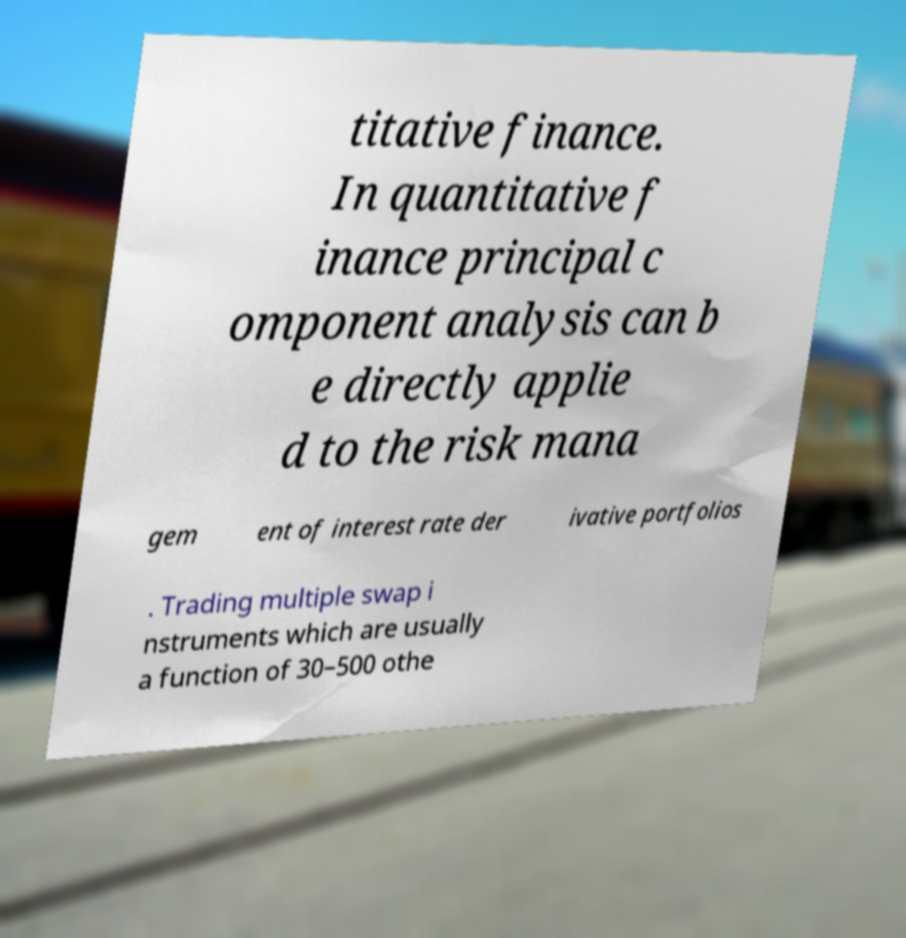What messages or text are displayed in this image? I need them in a readable, typed format. titative finance. In quantitative f inance principal c omponent analysis can b e directly applie d to the risk mana gem ent of interest rate der ivative portfolios . Trading multiple swap i nstruments which are usually a function of 30–500 othe 